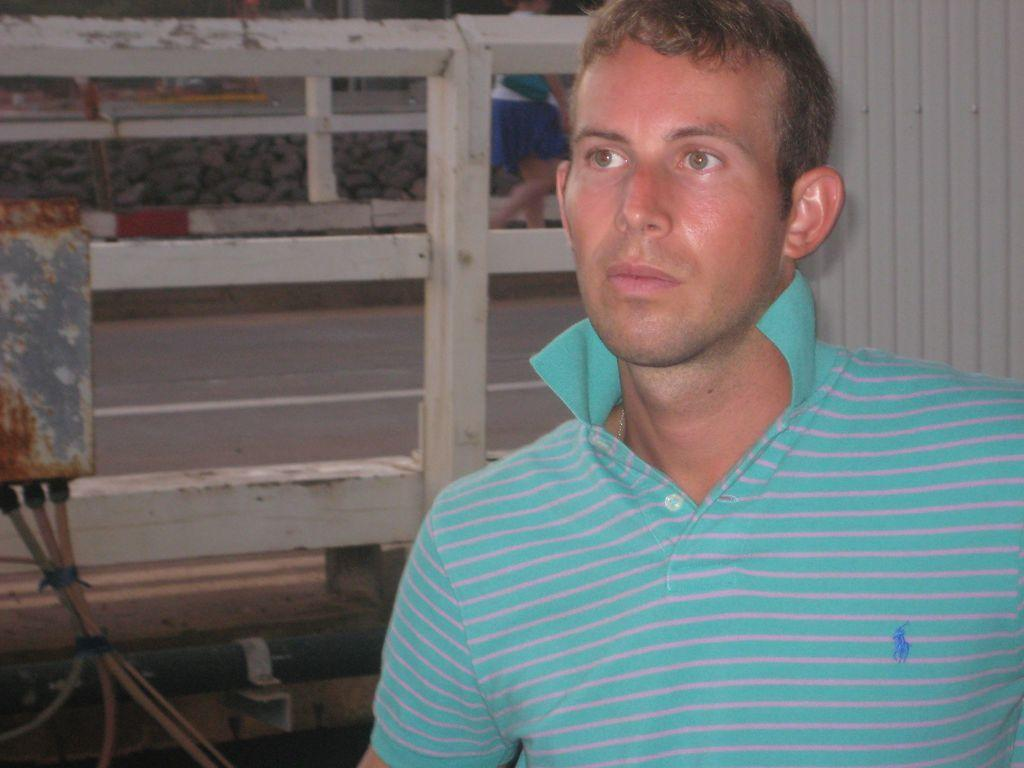Who is the main subject in the image? There is a person in the center of the image. What can be seen in the background of the image? There is a wall, a road, a woman, and stones in the background of the image. What color is the orange that the person is holding in the image? There is no orange present in the image. Is the person taking a bath in the image? There is no indication of a bath or any water-related activity in the image. 